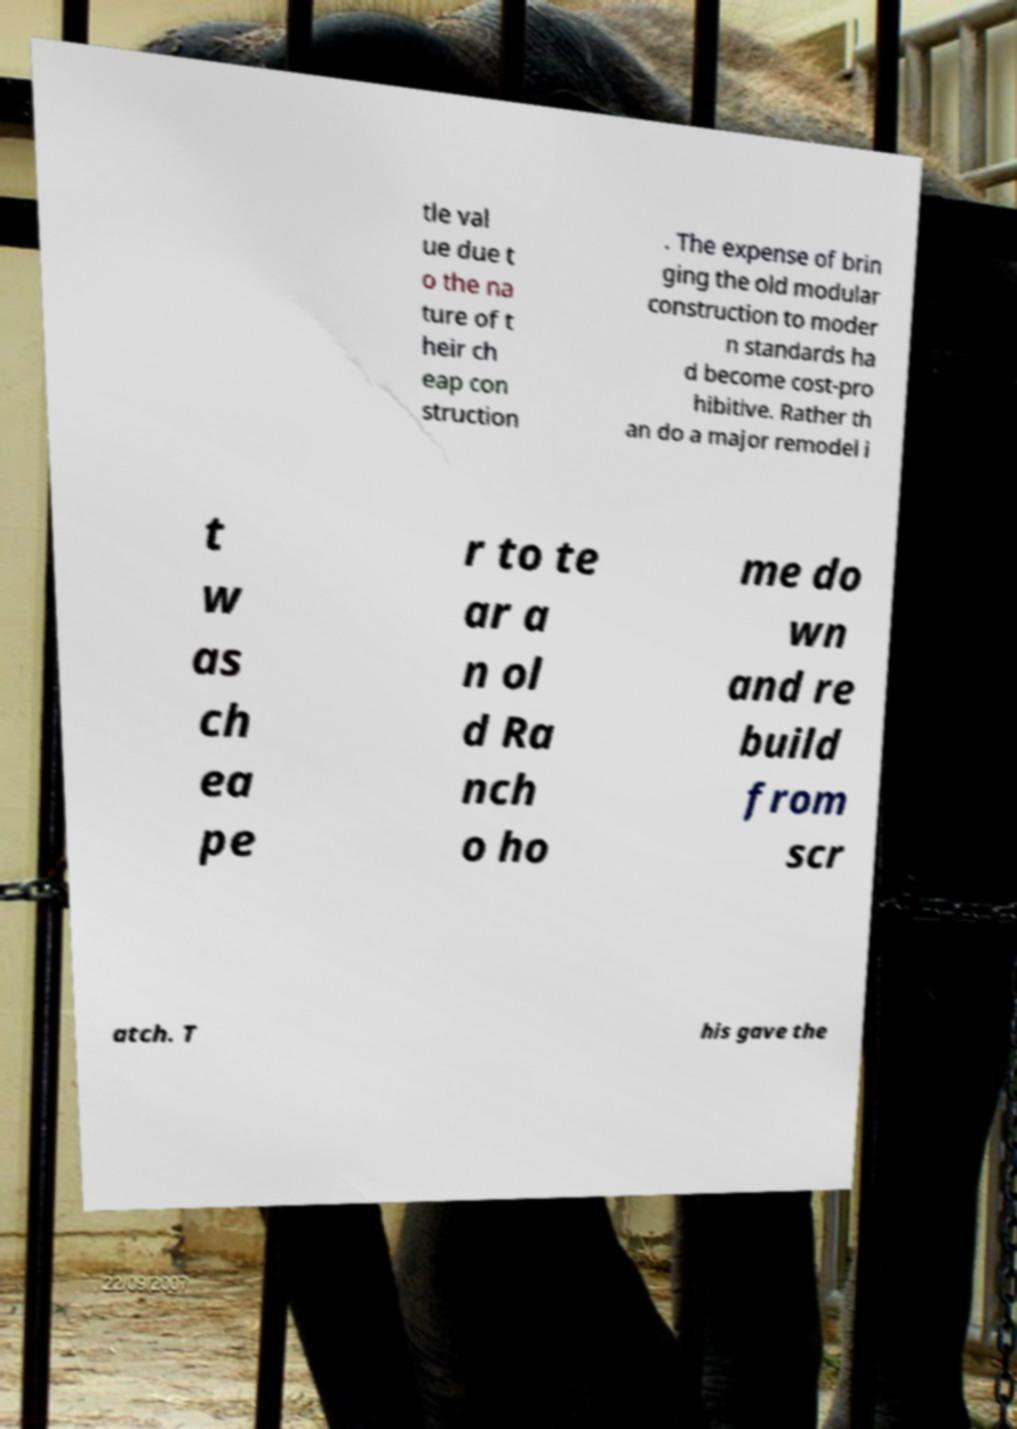For documentation purposes, I need the text within this image transcribed. Could you provide that? tle val ue due t o the na ture of t heir ch eap con struction . The expense of brin ging the old modular construction to moder n standards ha d become cost-pro hibitive. Rather th an do a major remodel i t w as ch ea pe r to te ar a n ol d Ra nch o ho me do wn and re build from scr atch. T his gave the 